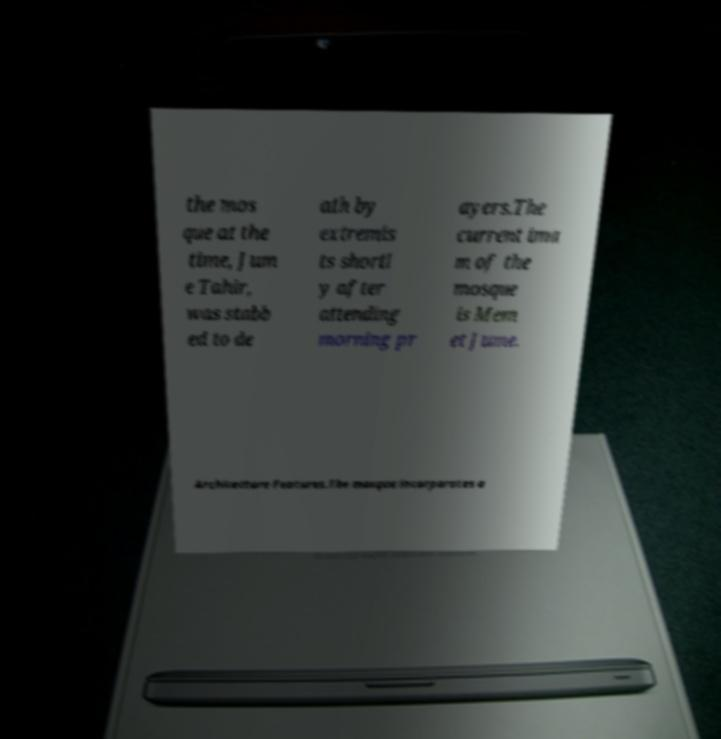Can you read and provide the text displayed in the image?This photo seems to have some interesting text. Can you extract and type it out for me? the mos que at the time, Jum e Tahir, was stabb ed to de ath by extremis ts shortl y after attending morning pr ayers.The current ima m of the mosque is Mem et Jume. Architecture Features.The mosque incorporates a 